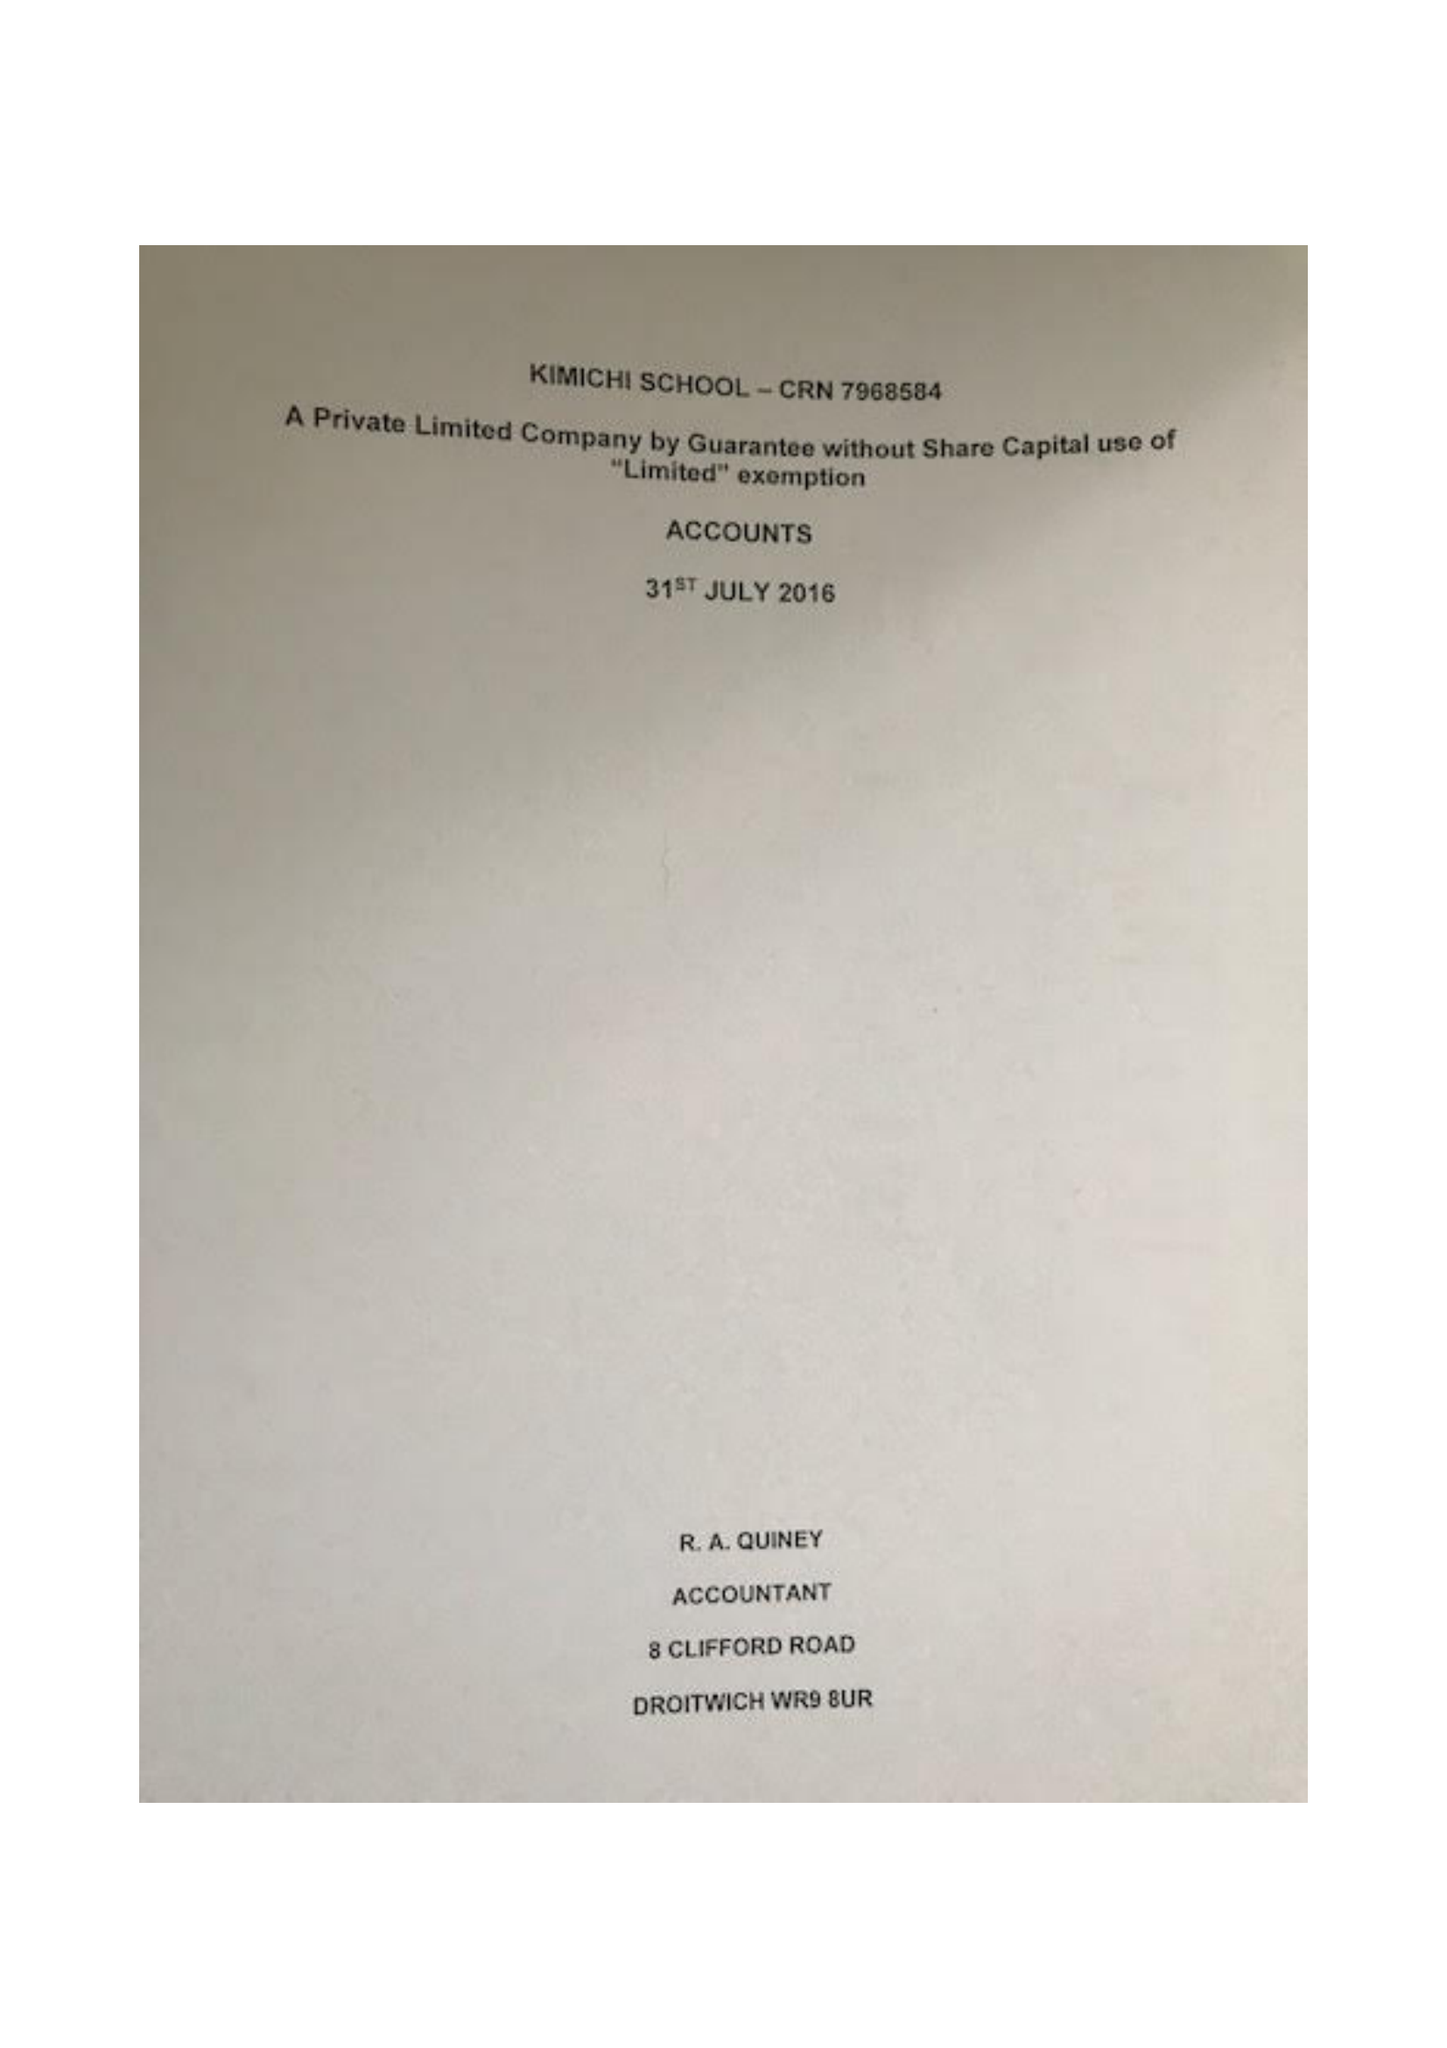What is the value for the income_annually_in_british_pounds?
Answer the question using a single word or phrase. 39113.00 